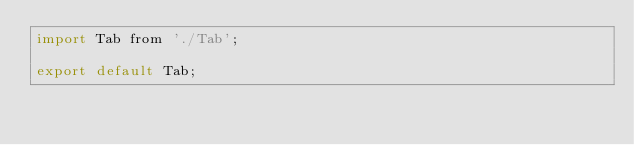<code> <loc_0><loc_0><loc_500><loc_500><_JavaScript_>import Tab from './Tab';

export default Tab;
</code> 